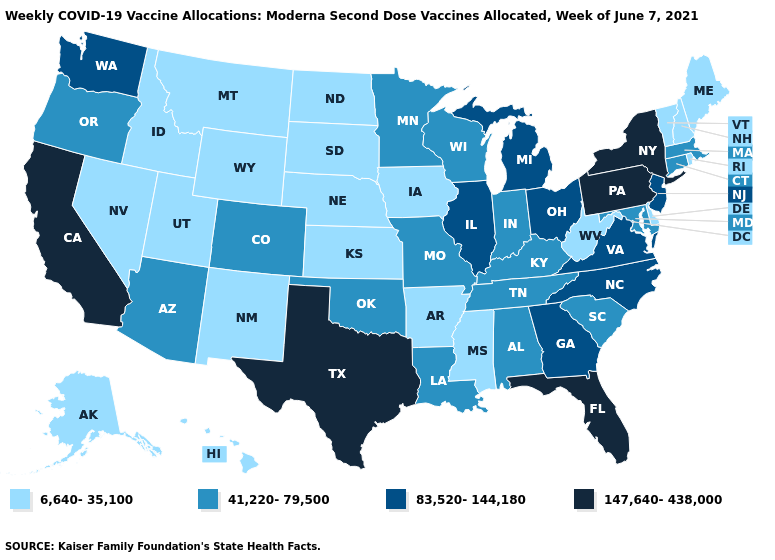What is the highest value in states that border Kentucky?
Concise answer only. 83,520-144,180. What is the value of Washington?
Concise answer only. 83,520-144,180. Does the map have missing data?
Short answer required. No. Which states have the lowest value in the Northeast?
Give a very brief answer. Maine, New Hampshire, Rhode Island, Vermont. What is the lowest value in states that border New Hampshire?
Quick response, please. 6,640-35,100. What is the value of Oregon?
Keep it brief. 41,220-79,500. What is the lowest value in states that border Washington?
Concise answer only. 6,640-35,100. Which states have the lowest value in the Northeast?
Short answer required. Maine, New Hampshire, Rhode Island, Vermont. Name the states that have a value in the range 83,520-144,180?
Short answer required. Georgia, Illinois, Michigan, New Jersey, North Carolina, Ohio, Virginia, Washington. Which states hav the highest value in the South?
Give a very brief answer. Florida, Texas. Which states hav the highest value in the Northeast?
Give a very brief answer. New York, Pennsylvania. Which states have the highest value in the USA?
Be succinct. California, Florida, New York, Pennsylvania, Texas. What is the lowest value in the West?
Be succinct. 6,640-35,100. What is the value of Tennessee?
Be succinct. 41,220-79,500. Which states have the lowest value in the USA?
Give a very brief answer. Alaska, Arkansas, Delaware, Hawaii, Idaho, Iowa, Kansas, Maine, Mississippi, Montana, Nebraska, Nevada, New Hampshire, New Mexico, North Dakota, Rhode Island, South Dakota, Utah, Vermont, West Virginia, Wyoming. 